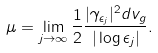Convert formula to latex. <formula><loc_0><loc_0><loc_500><loc_500>\mu = \lim _ { j \to \infty } \frac { 1 } { 2 } \frac { | \gamma _ { \epsilon _ { j } } | ^ { 2 } d v _ { g } } { | \log \epsilon _ { j } | } .</formula> 